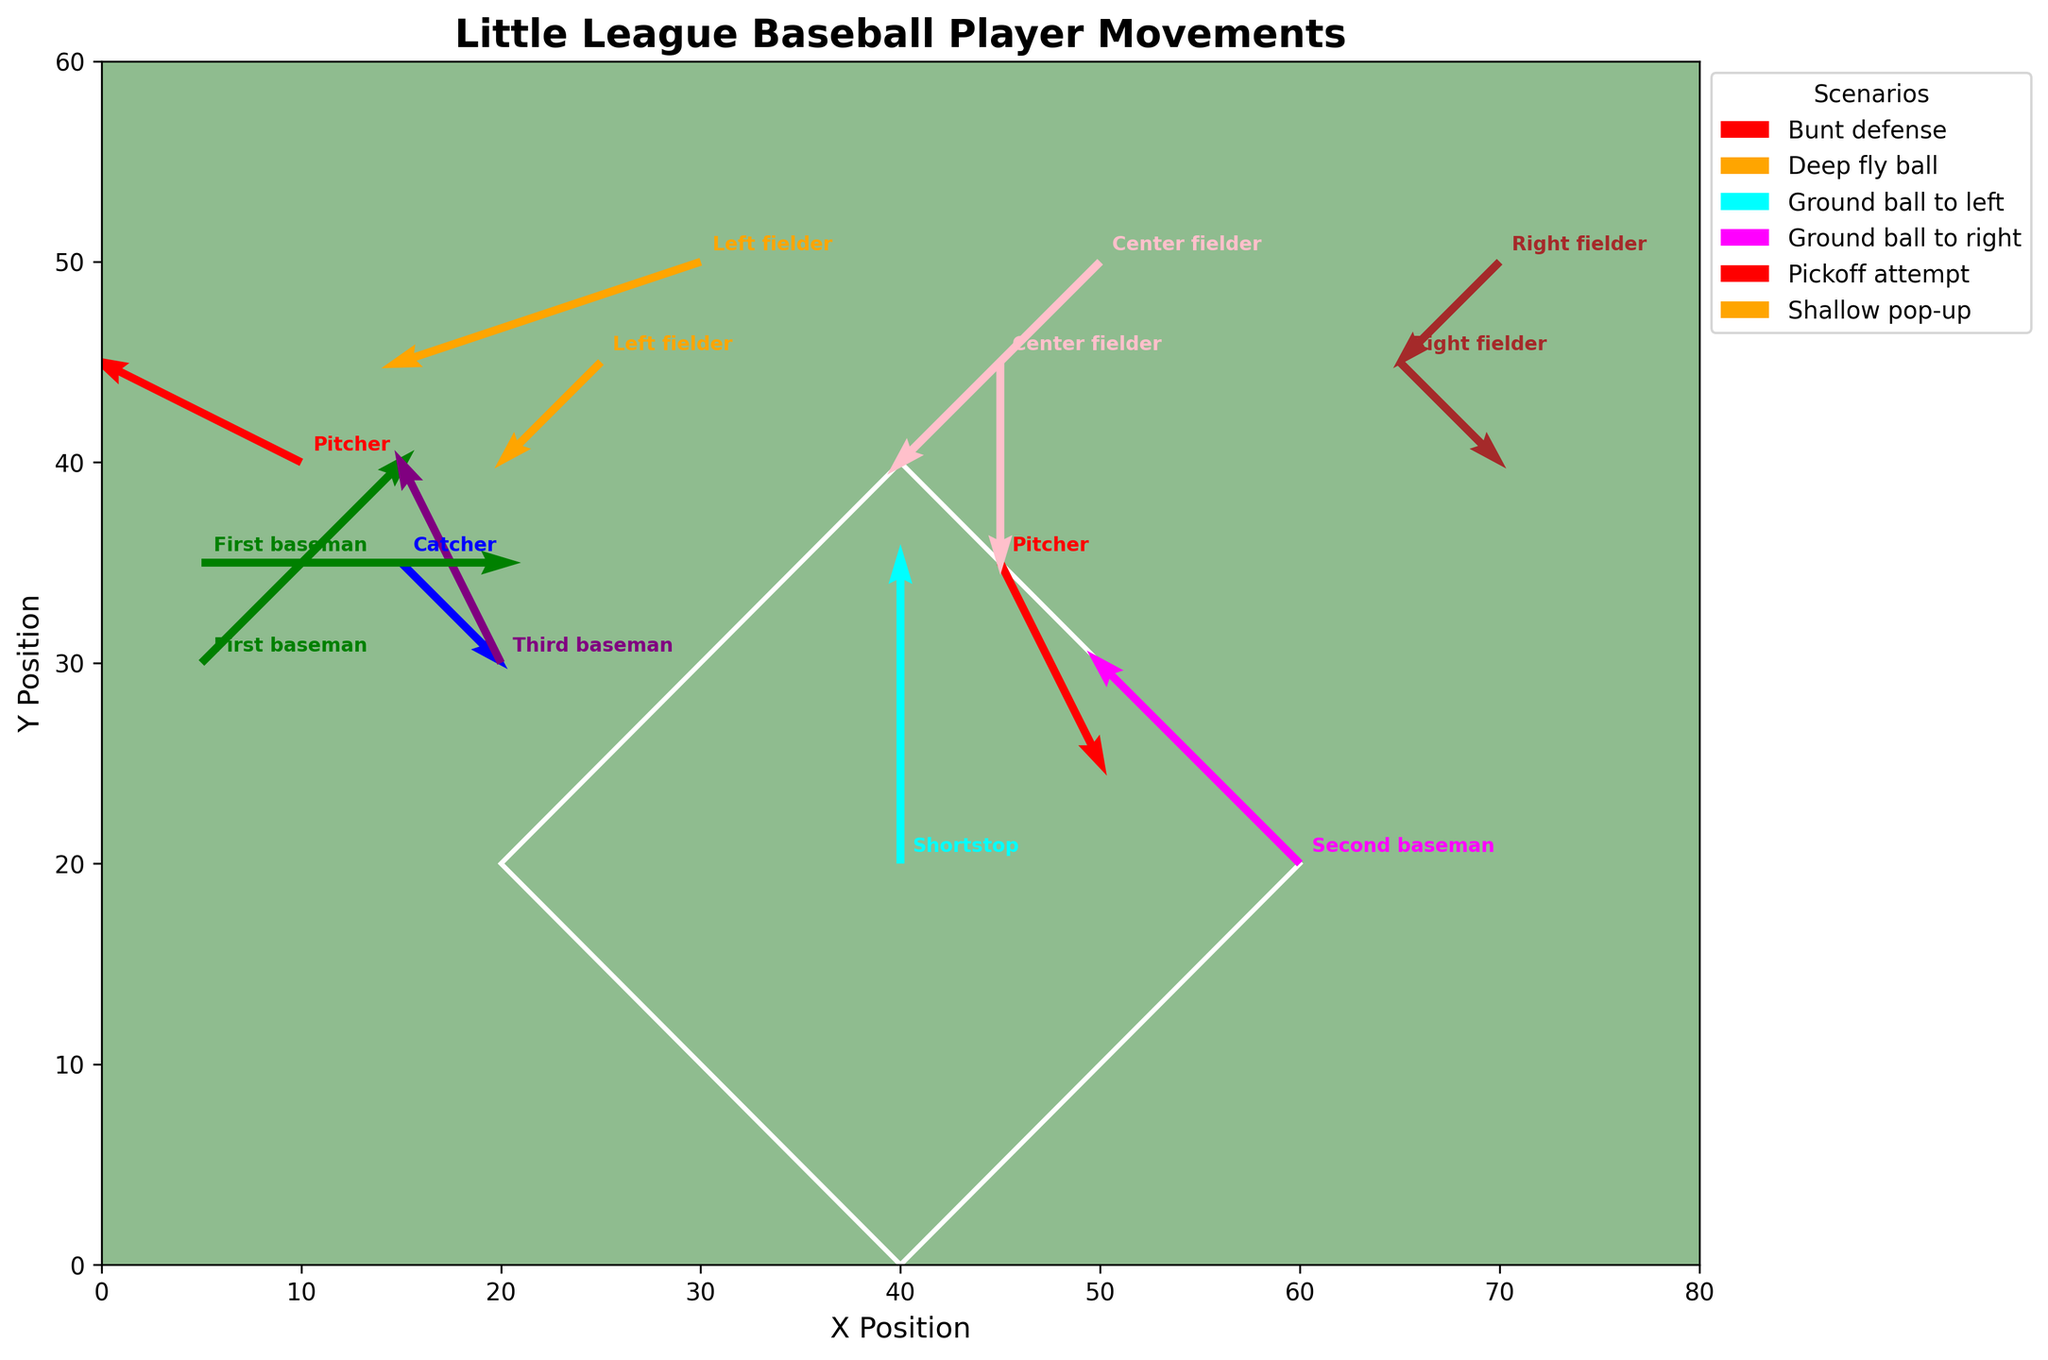What's the main color used for the field's background? The field's background color is specified as a light green, which is commonly used to represent the grassy area of a baseball field.
Answer: Light green How many fielders are involved in the "Deep fly ball" scenario? The data for the "Deep fly ball" scenario involves three players: Left fielder, Center fielder, and Right fielder.
Answer: 3 Which player moves the most during a "Pickoff attempt"? In the "Pickoff attempt" scenario, the First baseman moves 3 units to the right while the Pitcher only moves 1 unit right and 2 units down. Therefore, the First baseman moves the most.
Answer: First baseman What is the direction of the Pitcher in the "Bunt defense" scenario? The Pitcher in the "Bunt defense" scenario moves 2 units left and 1 unit up. This indicates a northwest direction.
Answer: Northwest Which scenario shows the most defensive movement by the Second baseman? The "Ground ball to right" scenario has the Second baseman moving 2 units to the left and 2 units up, which is the most movement indicated for this player position.
Answer: Ground ball to right Compare the movements of the Center fielder in the "Shallow pop-up" and "Deep fly ball" scenarios. Which one shows more significant movement? In the "Shallow pop-up" scenario, the Center fielder moves 2 units down. In the "Deep fly ball" scenario, the Center fielder moves 2 units left and 2 units down, indicating more overall movement in the "Deep fly ball" scenario.
Answer: Deep fly ball Which scenario involves both the Shortstop and the Second baseman moving? The "Ground ball to right" scenario involves the Second baseman and the "Ground ball to left" scenario involves the Shortstop, but no single scenario involves both.
Answer: None What is the total horizontal distance moved by the First baseman in all scenarios combined? The sum of the horizontal distances moved by the First baseman is 2 units right in the "Bunt defense" scenario plus 3 units right in the "Pickoff attempt" scenario, which equals 5 units.
Answer: 5 units For the "Bunt defense" scenario, which player moves vertically the least and what is their movement? In the "Bunt defense" scenario, the Catcher moves 1 unit down, which is the least vertical movement among the players in this scenario.
Answer: Catcher, 1 unit down What is the overall direction of the Right fielder's movement in the "Shallow pop-up" scenario? The Right fielder moves 1 unit right and 1 unit down in the "Shallow pop-up" scenario, indicating a southeast direction.
Answer: Southeast 